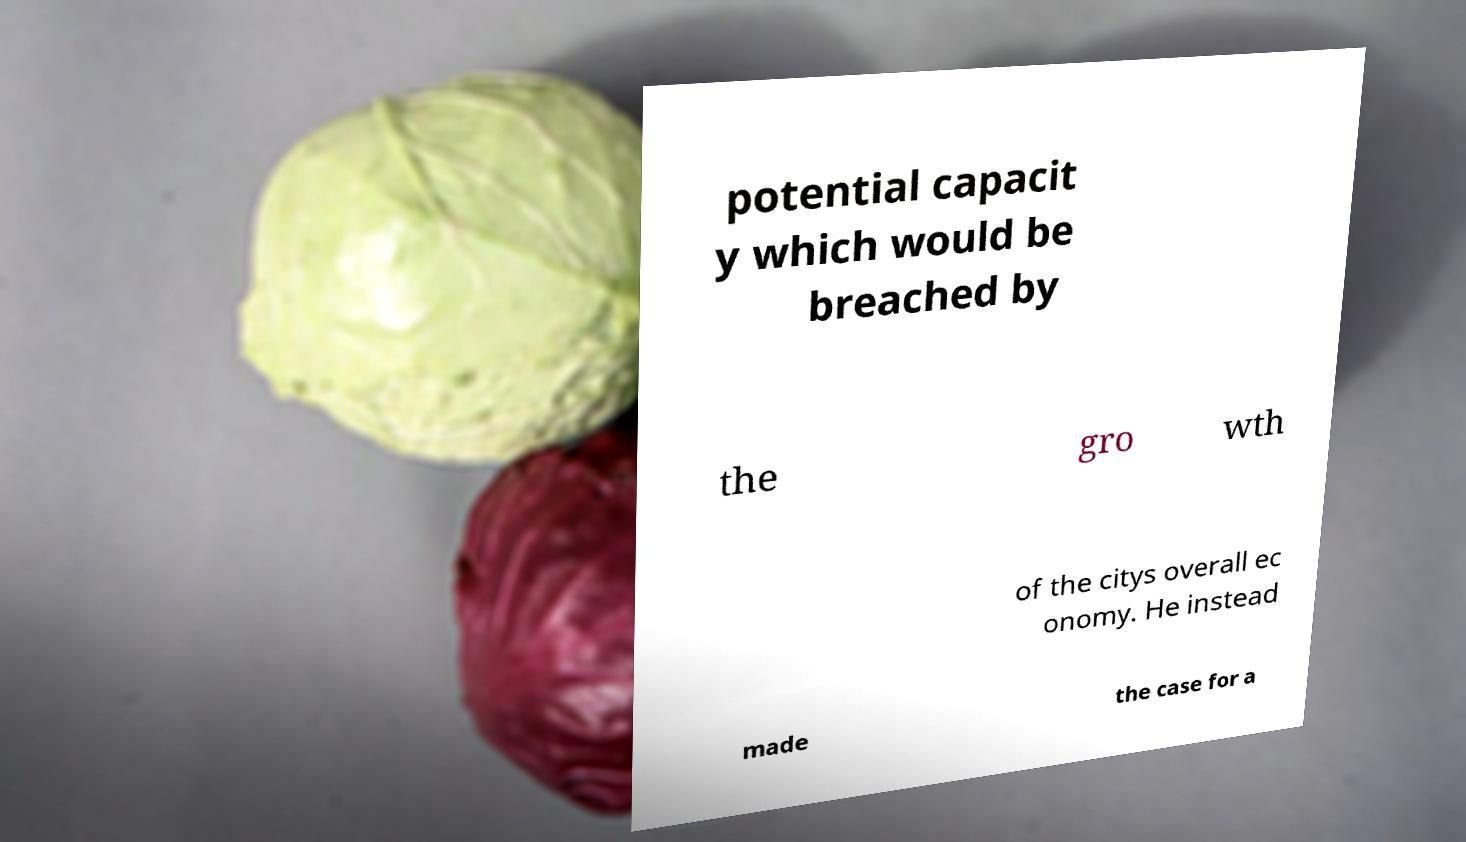Please read and relay the text visible in this image. What does it say? potential capacit y which would be breached by the gro wth of the citys overall ec onomy. He instead made the case for a 